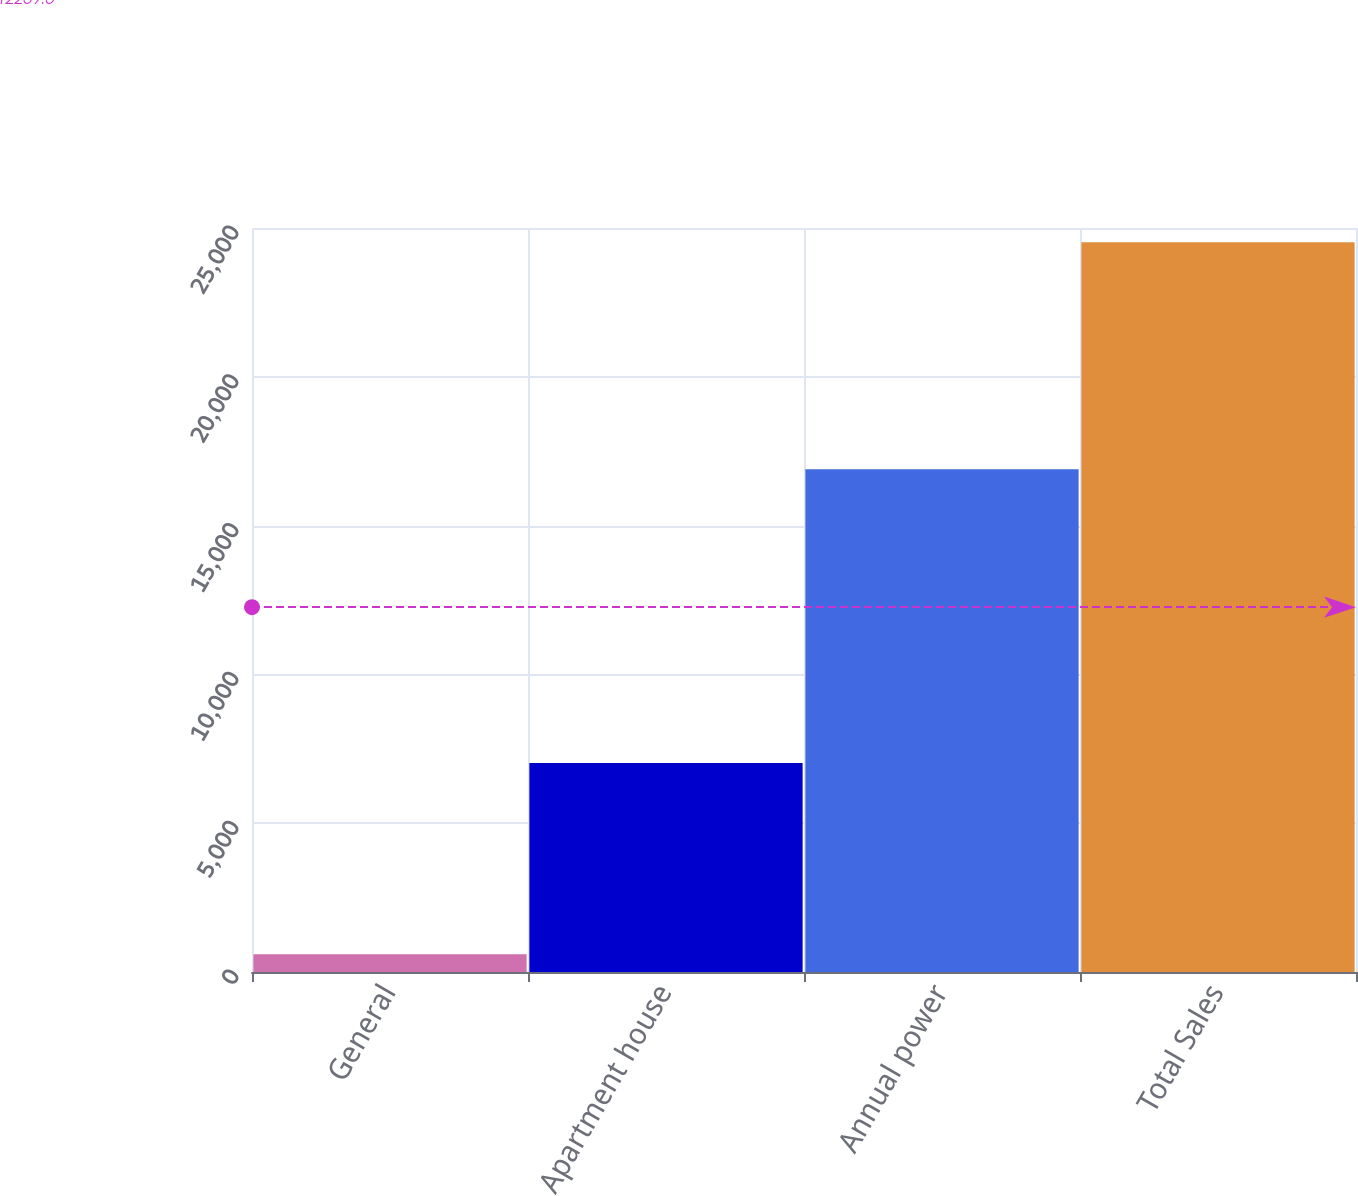<chart> <loc_0><loc_0><loc_500><loc_500><bar_chart><fcel>General<fcel>Apartment house<fcel>Annual power<fcel>Total Sales<nl><fcel>600<fcel>7022<fcel>16897<fcel>24519<nl></chart> 